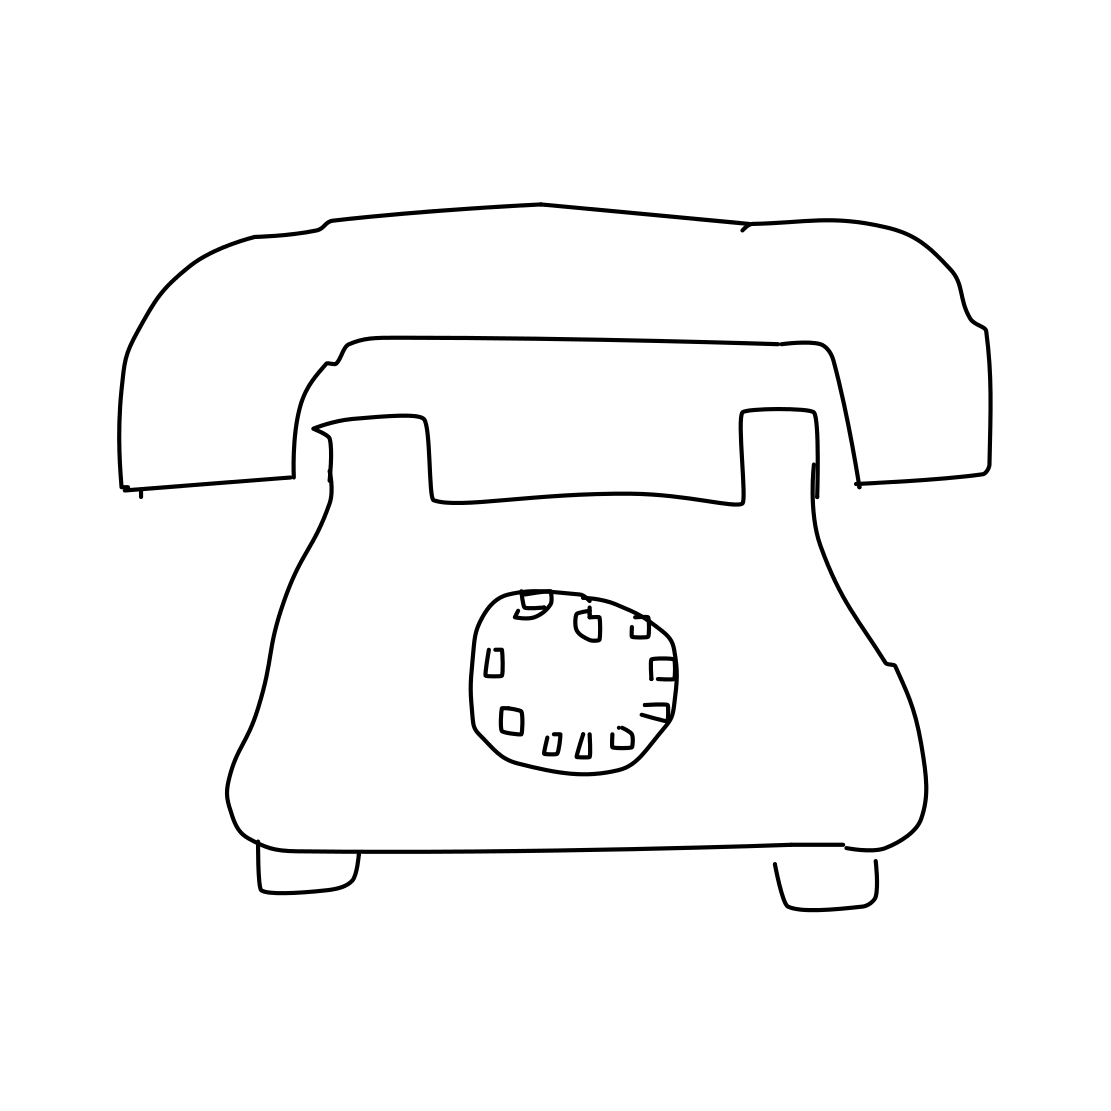How would someone use this type of telephone compared to modern smartphones? To use this rotary telephone, one would place a finger in the appropriate hole of the dial for each number and turn it clockwise until it reached the finger stop. The process is repeated for each number in the sequence to dial a number, which contrasts with the instantaneous tapping and swiping on touchscreens of modern smartphones. 